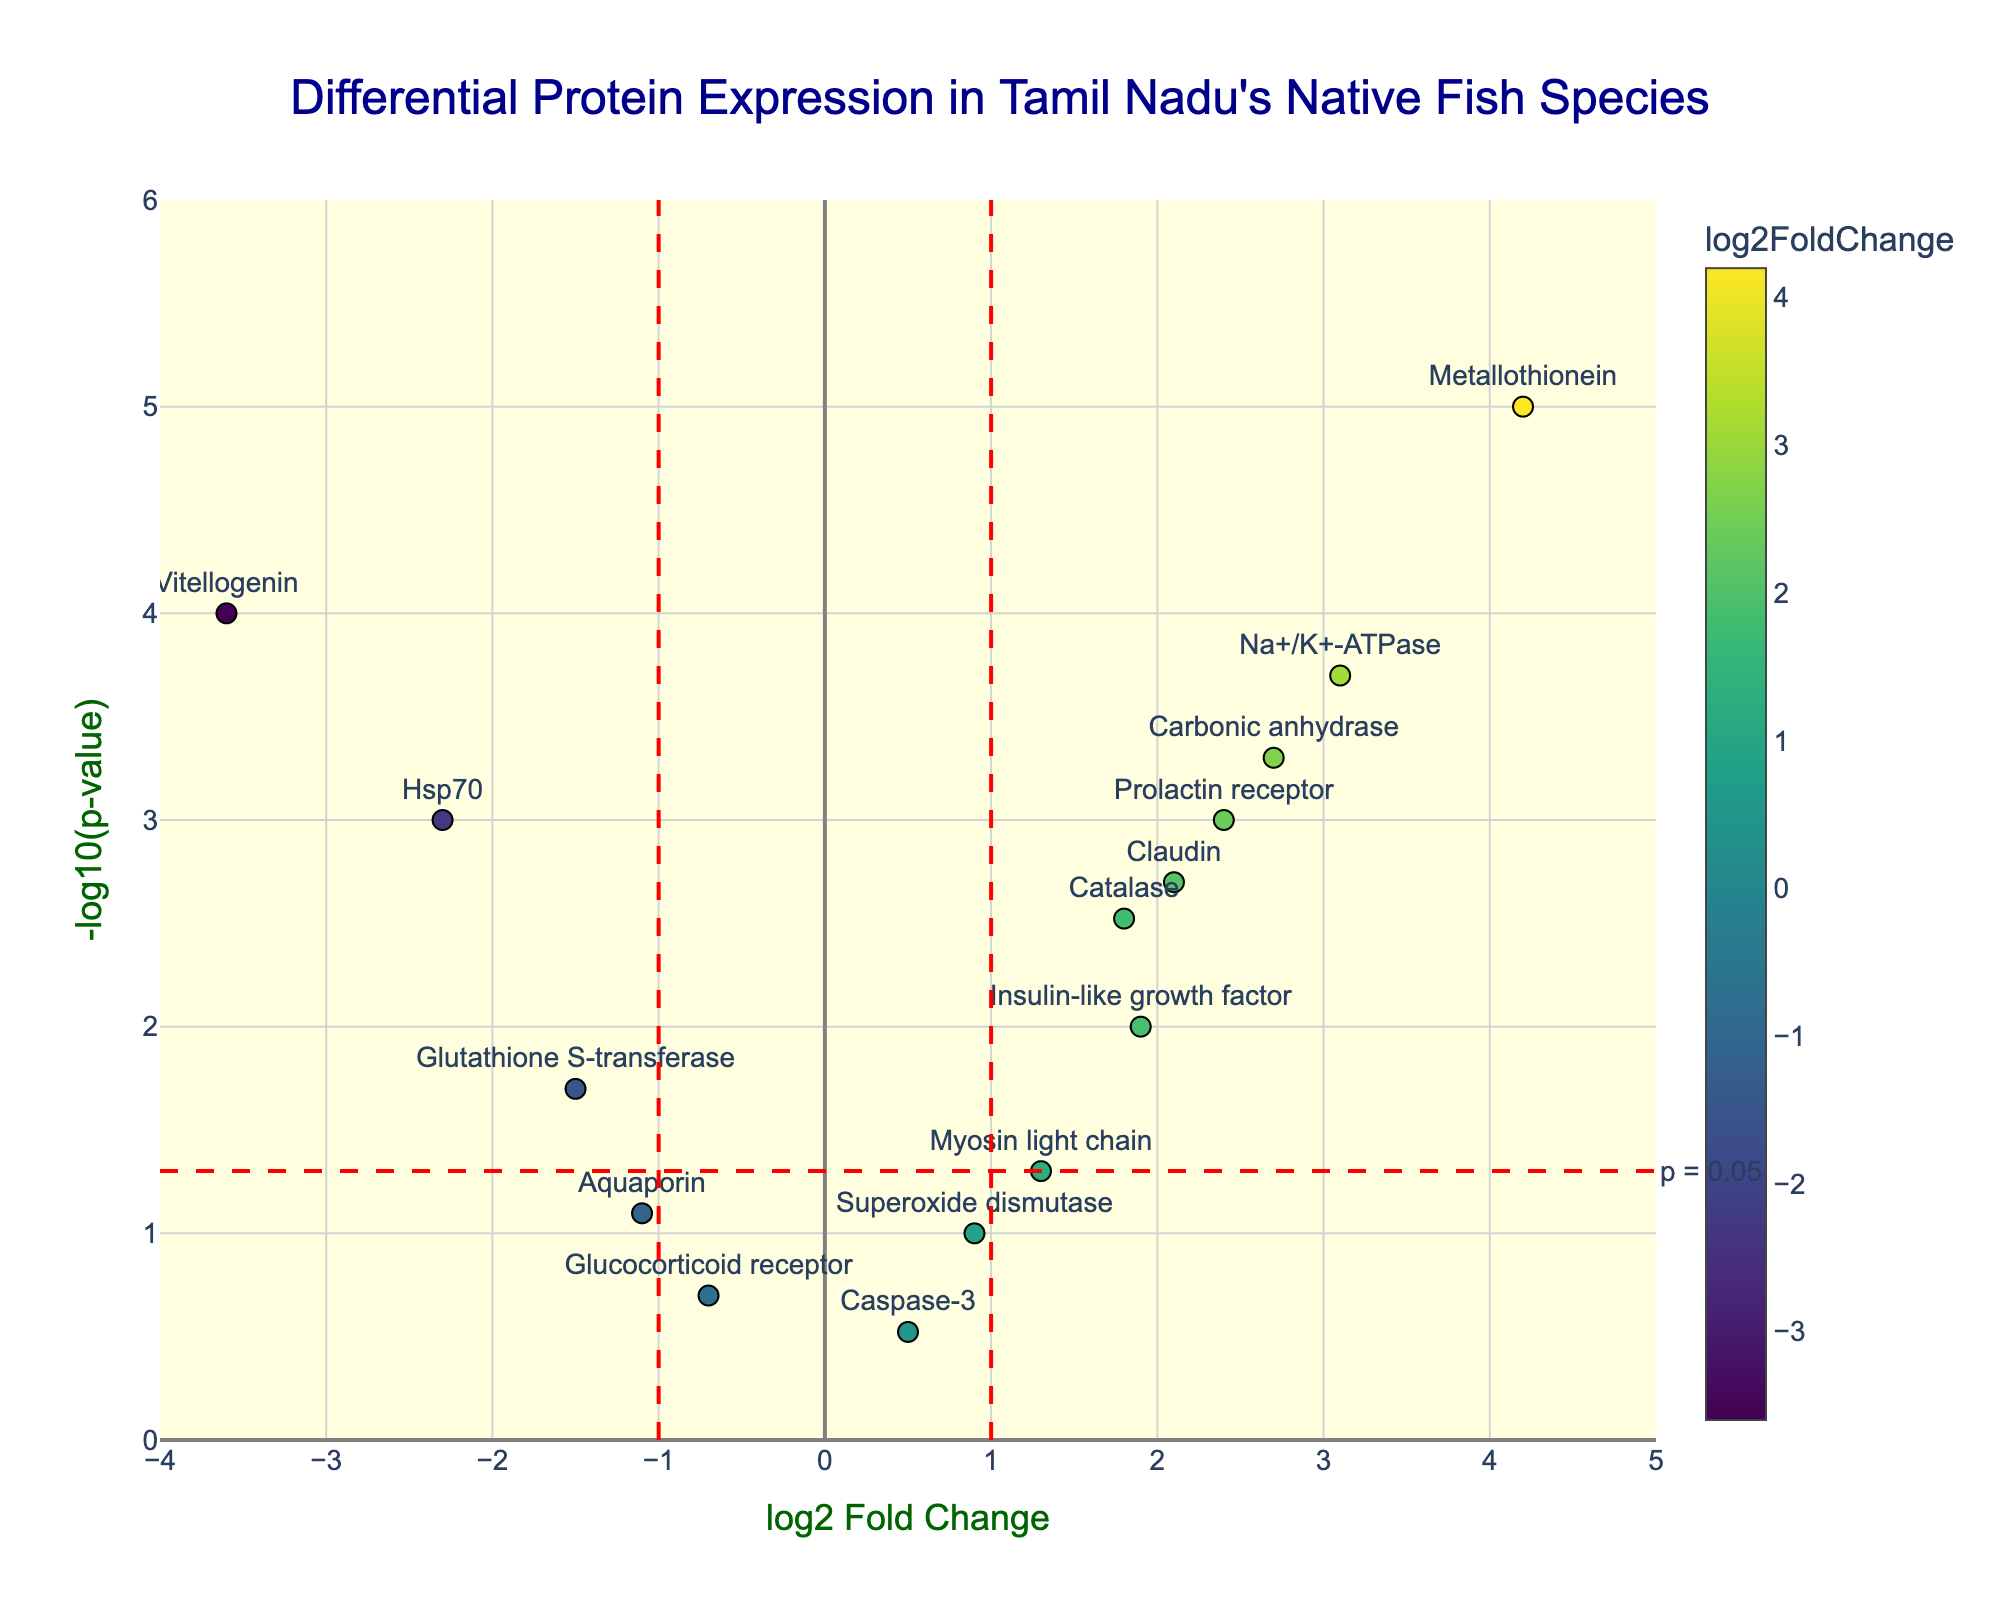What is the title of the plot? The title is found at the top of the plot, which provides context for what is being visualized.
Answer: Differential Protein Expression in Tamil Nadu's Native Fish Species What do the x-axis and y-axis represent? The x-axis shows the log2 Fold Change, indicating the magnitude and direction of expression change, while the y-axis represents the -log10(p-value), indicating the statistical significance of the changes.
Answer: log2 Fold Change and -log10(p-value) How many proteins have a p-value less than 0.05? Proteins with a -log10(p-value) higher than -log10(0.05) are plotted above the red dashed horizontal line, indicating statistical significance. Counting these gives us the total number.
Answer: 10 Which protein has the highest fold change? The highest fold change is the furthest right point on the x-axis.
Answer: Metallothionein Which protein is the most downregulated? The most downregulated protein is the furthest left point on the x-axis.
Answer: Vitellogenin What color is used for proteins with a negative log2 Fold Change? Proteins with negative log2 Fold Change values are represented with colors from the 'Viridis' color scale leaning towards darker or cooler colors.
Answer: Darker/cooler colors What is the log2 Fold Change and p-value for Na+/K+-ATPase? Hovering over or looking at the position in the plot, Na+/K+-ATPase is at x=3.1 (log2 Fold Change) and y=-log10(0.0002). Converting -log10(0.0002) to p-value gives 0.0002.
Answer: 3.1 and 0.0002 How many proteins are significantly upregulated with a log2 Fold Change greater than 1? Counting the points to the right of x=1 and above the red dashed horizontal line for p<0.05 identifies the significantly upregulated proteins.
Answer: 6 Which proteins are close to the significance threshold (p-value = 0.05)? Proteins near the red dashed horizontal line on the y-axis are close to the p-value threshold of 0.05.
Answer: Superoxide dismutase, Myosin light chain, Glutathione S-transferase, Aquaporin How does the fold change of Claudin compare to Carbonic anhydrase? By locating both on the x-axis and comparing their positions, Claudin is less upregulated than Carbonic anhydrase.
Answer: Claudin < Carbonic anhydrase 